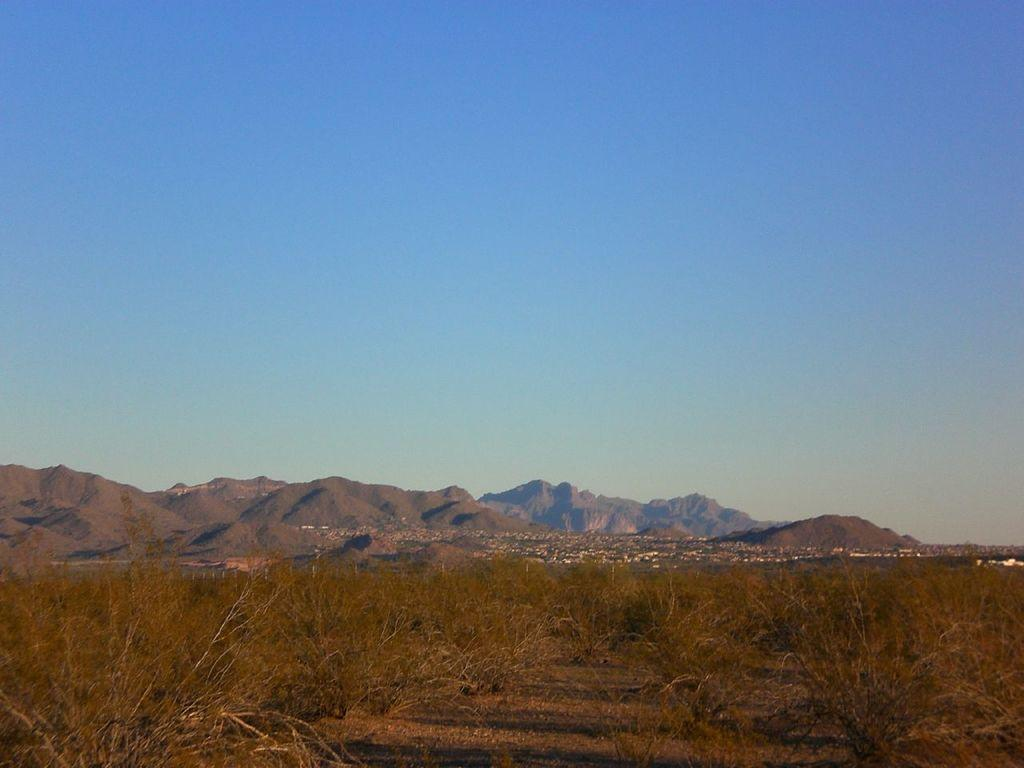What type of vegetation can be seen on the ground in the image? There are dried plants on the ground in the image. What can be seen in the distance behind the dried plants? There are hills visible in the background of the image. What is visible above the hills in the image? The sky is visible in the background of the image. What type of fuel is being used by the car in the image? There is no car present in the image, so it is not possible to determine what type of fuel is being used. 